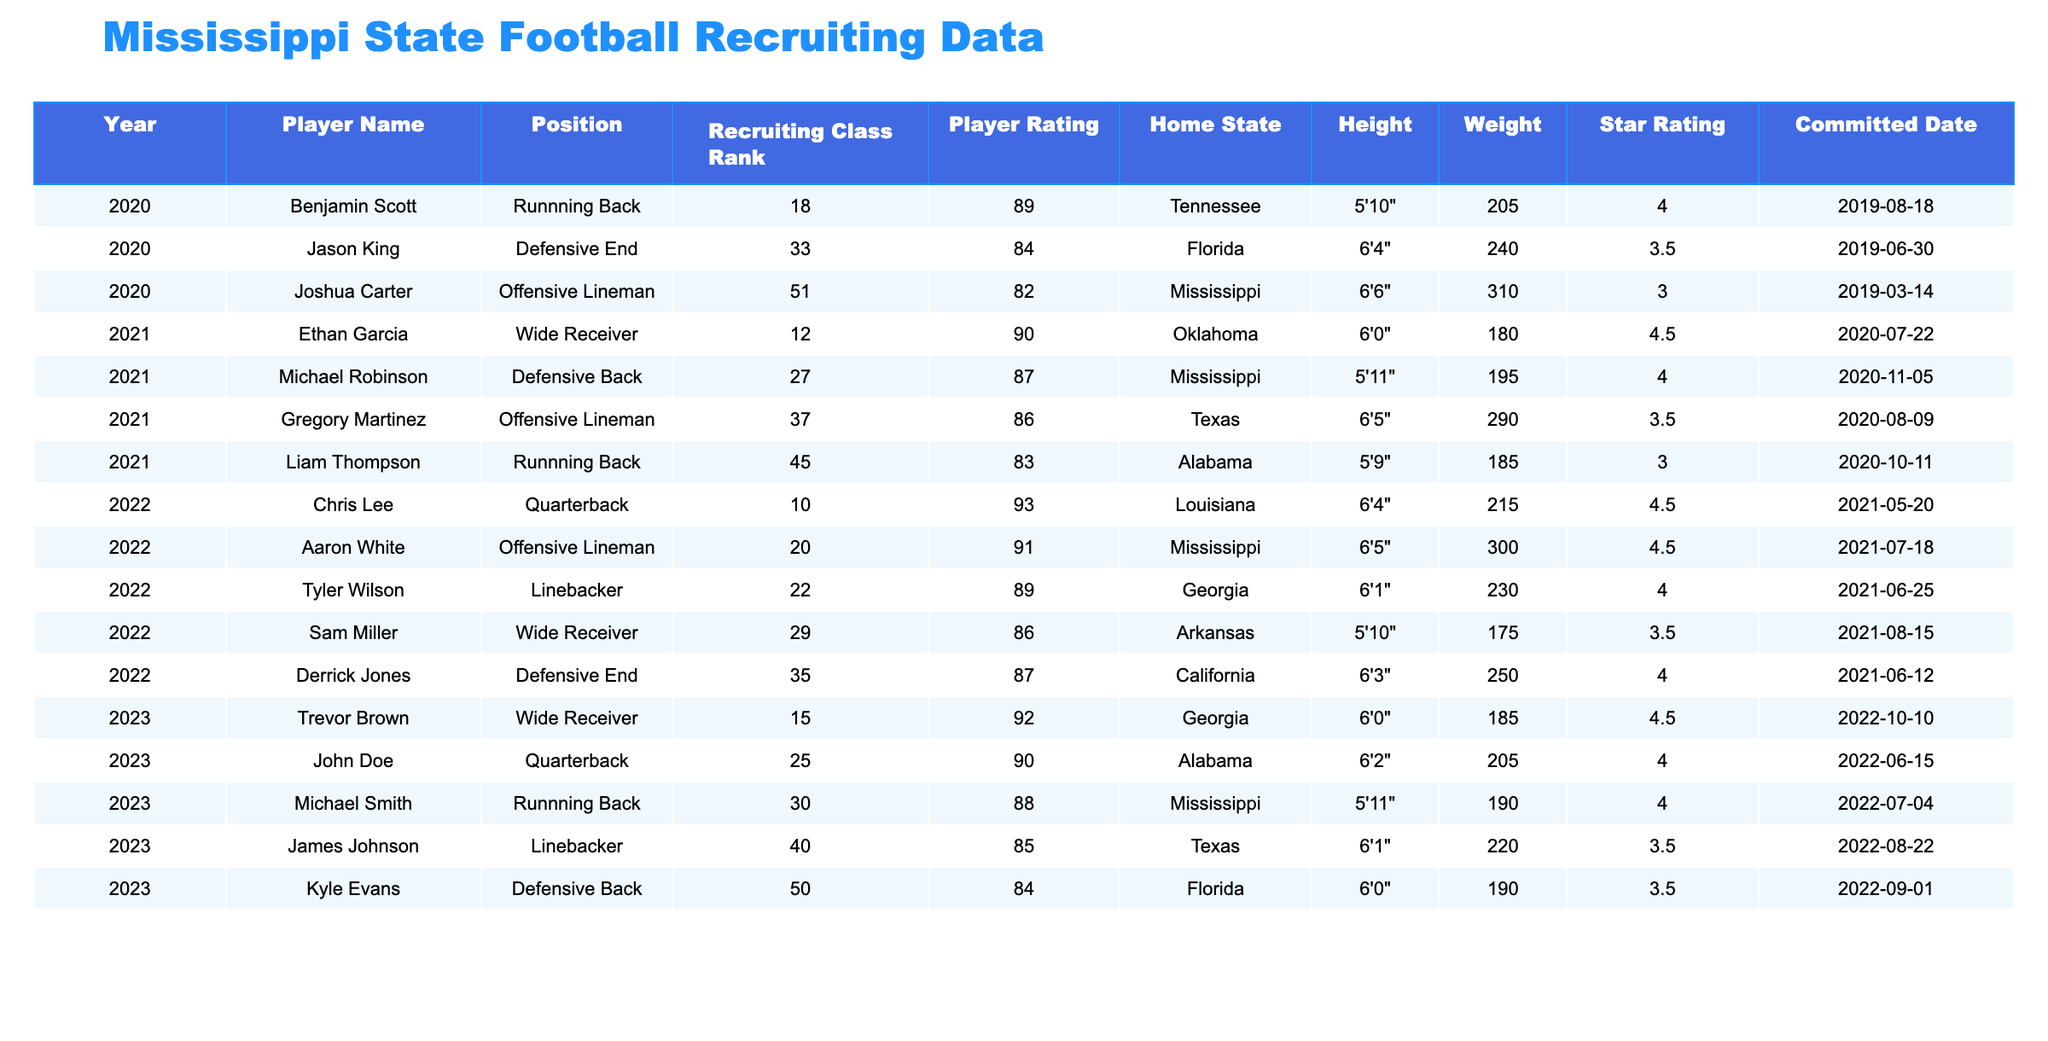What is the highest player rating for the 2023 recruiting class? The highest player rating in the 2023 recruiting class is found by checking each player's rating. Trevor Brown has a rating of 92, which is the highest among the listed players.
Answer: 92 Which player from the 2022 recruiting class has the highest star rating? By comparing the star ratings for the 2022 recruits, Chris Lee has the highest star rating of 4.5.
Answer: Chris Lee How many players from Mississippi were recruited in 2023? The table lists two players from Mississippi in 2023: Michael Smith and Kyle Evans. Therefore, the count is 2.
Answer: 2 What is the average height of players in the 2022 recruiting class? The heights of the players in the 2022 class are 6'5", 6'3", 6'4", 5'10", and 6'1". Converting these to inches gives us 77, 75, 76, 70, and 73. The average height is (77 + 75 + 76 + 70 + 73)/5 = 74.2 inches.
Answer: 74.2 inches Was there a player rated 90 or above in the 2021 recruiting class? Looking at the ratings for the 2021 players, the only player rated 90 or above is Ethan Garcia with a rating of 90. Therefore, yes, there was such a player.
Answer: Yes Which position had the most recruits in the 2023 class? In the 2023 class, there are five different positions listed: Quarterback, Running Back, Wide Receiver, Linebacker, and Defensive Back. The count does not exceed one per position so no position dominates.
Answer: None What is the total number of offensive linemen recruited from 2020 to 2023? Analyzing the table, only two offensive linemen are listed: Joshua Carter in 2020 and Aaron White in 2022. Thus, the total count is 2.
Answer: 2 Which year saw the highest star-rated player? Evaluating all years, Chris Lee in 2022 has the highest star rating of 4.5. Comparing this to 2023, where the highest is 4.5 as well, but in different positions. The highest star-rated player can be referred to in 2022.
Answer: 2022 Is there a defensive back with a rating lower than 85 in the data? The table specifies that the player Kyle Evans, a defensive back, has a rating of 84, which is lower than 85. Therefore, the answer is yes.
Answer: Yes What average weight do players from Georgia have in the recruiting classes? The weights of the players from Georgia in the table are 230 pounds (Tyler Wilson, 2022) and 185 pounds (Trevor Brown, 2023). So the average weight is (230 + 185) / 2 = 207.5 pounds.
Answer: 207.5 pounds 